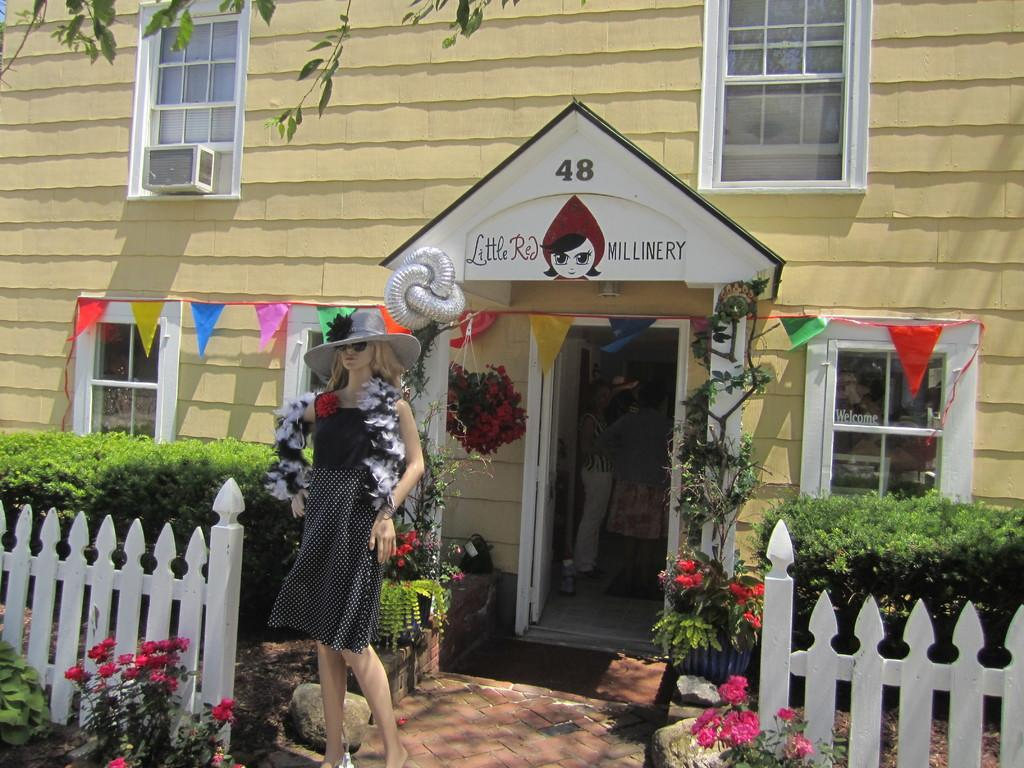What type of vegetation can be seen in the image? There are shrubs, flowers, and plants in the image. What structures are present in the image? There are fences in the image. Is there any human-made object in the image? Yes, there is a mannequin in the image. What type of building is shown in the image? The image shows a house. Can you describe the people inside the house? The facts provided do not give any information about the people inside the house. What type of fan is visible in the image? There is no fan present in the image. Can you describe the soap used by the people inside the house? There is no information about soap or the people's activities inside the house in the provided facts. 